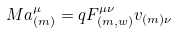Convert formula to latex. <formula><loc_0><loc_0><loc_500><loc_500>M a _ { ( m ) } ^ { \mu } = q F _ { ( m , w ) } ^ { \mu \nu } v _ { ( m ) \nu }</formula> 